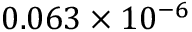Convert formula to latex. <formula><loc_0><loc_0><loc_500><loc_500>0 . 0 6 3 \times 1 0 ^ { - 6 }</formula> 